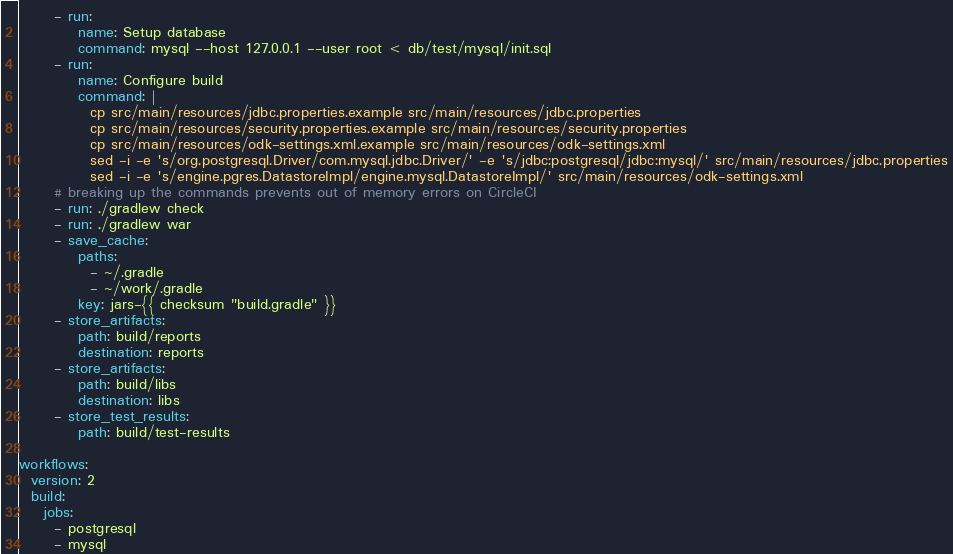<code> <loc_0><loc_0><loc_500><loc_500><_YAML_>      - run:
          name: Setup database
          command: mysql --host 127.0.0.1 --user root < db/test/mysql/init.sql
      - run:
          name: Configure build
          command: |
            cp src/main/resources/jdbc.properties.example src/main/resources/jdbc.properties
            cp src/main/resources/security.properties.example src/main/resources/security.properties
            cp src/main/resources/odk-settings.xml.example src/main/resources/odk-settings.xml
            sed -i -e 's/org.postgresql.Driver/com.mysql.jdbc.Driver/' -e 's/jdbc:postgresql/jdbc:mysql/' src/main/resources/jdbc.properties
            sed -i -e 's/engine.pgres.DatastoreImpl/engine.mysql.DatastoreImpl/' src/main/resources/odk-settings.xml
      # breaking up the commands prevents out of memory errors on CircleCI
      - run: ./gradlew check
      - run: ./gradlew war
      - save_cache:
          paths:
            - ~/.gradle
            - ~/work/.gradle
          key: jars-{{ checksum "build.gradle" }}
      - store_artifacts:
          path: build/reports
          destination: reports
      - store_artifacts:
          path: build/libs
          destination: libs
      - store_test_results:
          path: build/test-results

workflows:
  version: 2
  build:
    jobs:
      - postgresql
      - mysql</code> 